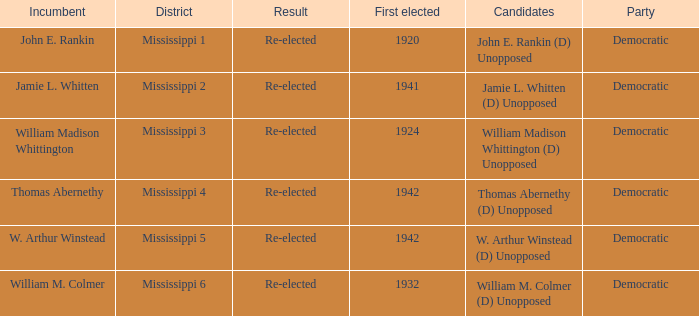What is the result for w. arthur winstead? Re-elected. 